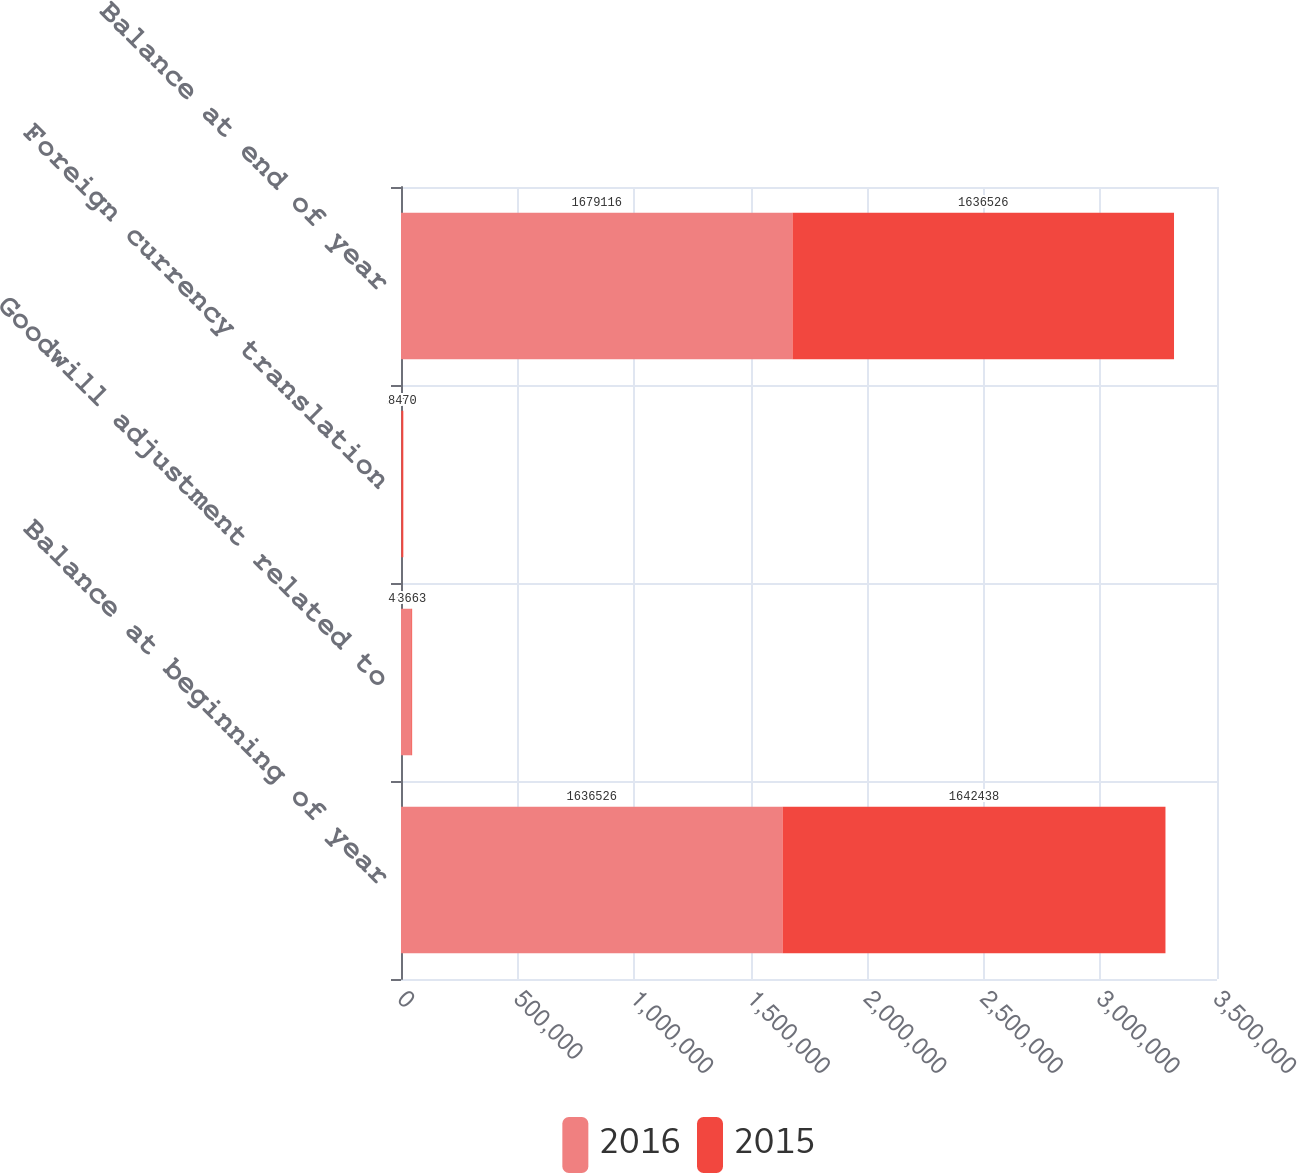Convert chart. <chart><loc_0><loc_0><loc_500><loc_500><stacked_bar_chart><ecel><fcel>Balance at beginning of year<fcel>Goodwill adjustment related to<fcel>Foreign currency translation<fcel>Balance at end of year<nl><fcel>2016<fcel>1.63653e+06<fcel>44046<fcel>1456<fcel>1.67912e+06<nl><fcel>2015<fcel>1.64244e+06<fcel>3663<fcel>8470<fcel>1.63653e+06<nl></chart> 